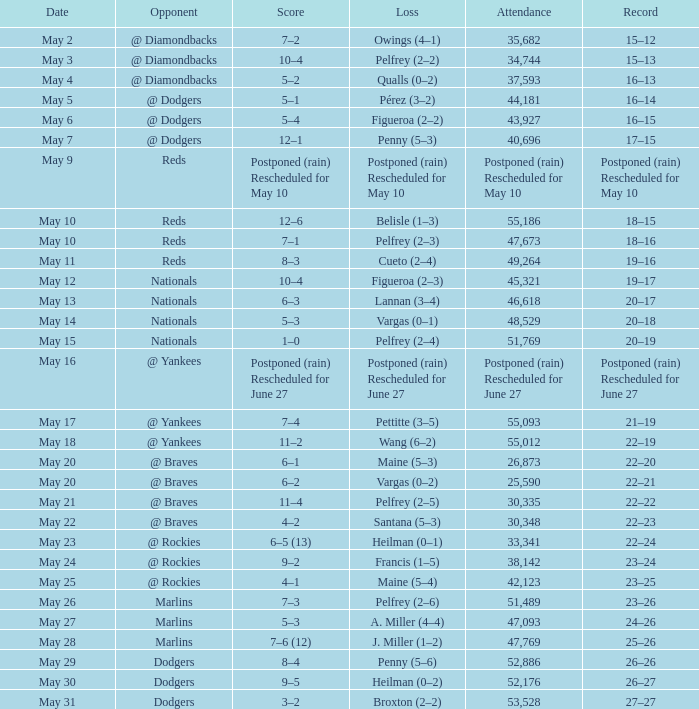Score of postponed (rain) rescheduled for June 27 had what loss? Postponed (rain) Rescheduled for June 27. 